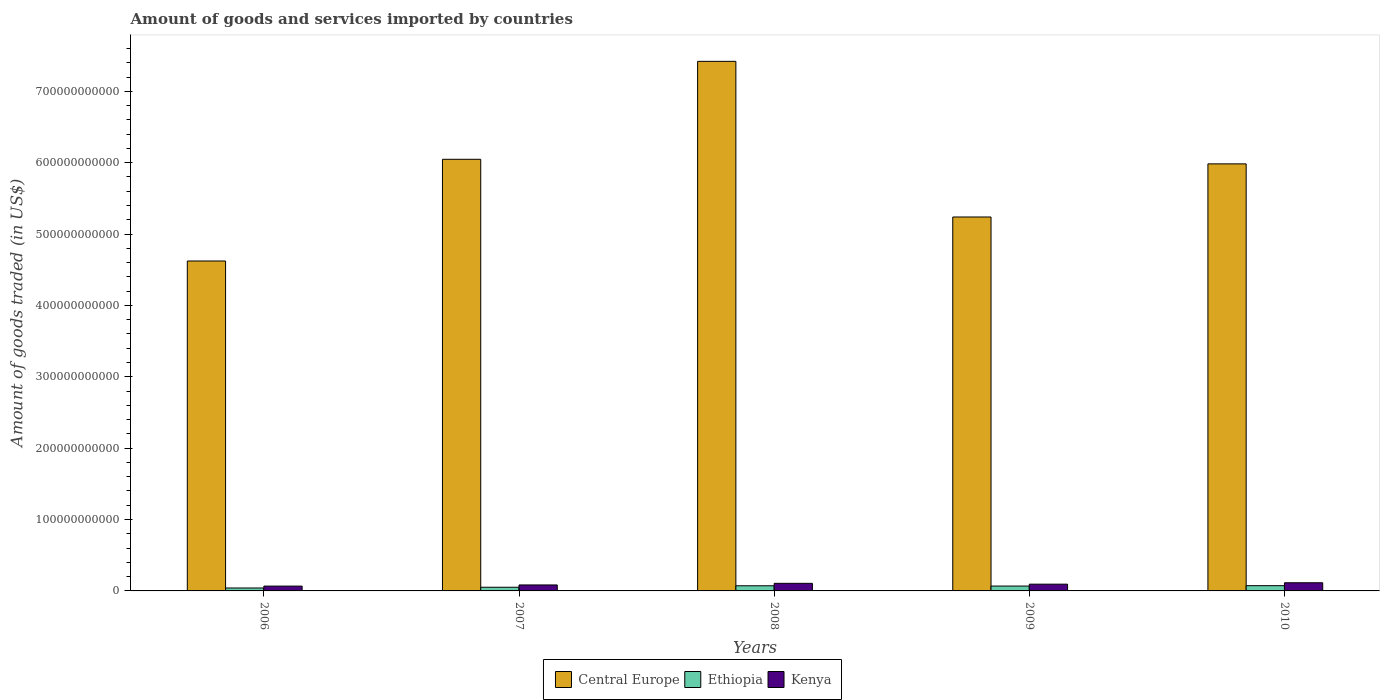How many different coloured bars are there?
Provide a succinct answer. 3. What is the label of the 4th group of bars from the left?
Your answer should be compact. 2009. In how many cases, is the number of bars for a given year not equal to the number of legend labels?
Your answer should be very brief. 0. What is the total amount of goods and services imported in Ethiopia in 2006?
Make the answer very short. 4.11e+09. Across all years, what is the maximum total amount of goods and services imported in Ethiopia?
Ensure brevity in your answer.  7.36e+09. Across all years, what is the minimum total amount of goods and services imported in Kenya?
Provide a succinct answer. 6.75e+09. In which year was the total amount of goods and services imported in Central Europe maximum?
Provide a short and direct response. 2008. In which year was the total amount of goods and services imported in Kenya minimum?
Keep it short and to the point. 2006. What is the total total amount of goods and services imported in Central Europe in the graph?
Offer a terse response. 2.93e+12. What is the difference between the total amount of goods and services imported in Ethiopia in 2009 and that in 2010?
Make the answer very short. -5.45e+08. What is the difference between the total amount of goods and services imported in Central Europe in 2008 and the total amount of goods and services imported in Ethiopia in 2010?
Your answer should be compact. 7.35e+11. What is the average total amount of goods and services imported in Kenya per year?
Your response must be concise. 9.33e+09. In the year 2010, what is the difference between the total amount of goods and services imported in Kenya and total amount of goods and services imported in Ethiopia?
Offer a very short reply. 4.08e+09. What is the ratio of the total amount of goods and services imported in Kenya in 2007 to that in 2008?
Keep it short and to the point. 0.79. Is the total amount of goods and services imported in Ethiopia in 2008 less than that in 2010?
Offer a terse response. Yes. Is the difference between the total amount of goods and services imported in Kenya in 2009 and 2010 greater than the difference between the total amount of goods and services imported in Ethiopia in 2009 and 2010?
Ensure brevity in your answer.  No. What is the difference between the highest and the second highest total amount of goods and services imported in Ethiopia?
Offer a terse response. 1.58e+08. What is the difference between the highest and the lowest total amount of goods and services imported in Kenya?
Ensure brevity in your answer.  4.69e+09. What does the 2nd bar from the left in 2007 represents?
Make the answer very short. Ethiopia. What does the 2nd bar from the right in 2009 represents?
Offer a terse response. Ethiopia. How many years are there in the graph?
Provide a short and direct response. 5. What is the difference between two consecutive major ticks on the Y-axis?
Make the answer very short. 1.00e+11. Are the values on the major ticks of Y-axis written in scientific E-notation?
Your response must be concise. No. Does the graph contain any zero values?
Make the answer very short. No. How many legend labels are there?
Make the answer very short. 3. How are the legend labels stacked?
Provide a short and direct response. Horizontal. What is the title of the graph?
Offer a very short reply. Amount of goods and services imported by countries. Does "Malta" appear as one of the legend labels in the graph?
Your response must be concise. No. What is the label or title of the X-axis?
Ensure brevity in your answer.  Years. What is the label or title of the Y-axis?
Offer a terse response. Amount of goods traded (in US$). What is the Amount of goods traded (in US$) of Central Europe in 2006?
Offer a very short reply. 4.62e+11. What is the Amount of goods traded (in US$) of Ethiopia in 2006?
Offer a terse response. 4.11e+09. What is the Amount of goods traded (in US$) of Kenya in 2006?
Offer a very short reply. 6.75e+09. What is the Amount of goods traded (in US$) of Central Europe in 2007?
Ensure brevity in your answer.  6.05e+11. What is the Amount of goods traded (in US$) in Ethiopia in 2007?
Your response must be concise. 5.16e+09. What is the Amount of goods traded (in US$) of Kenya in 2007?
Give a very brief answer. 8.37e+09. What is the Amount of goods traded (in US$) in Central Europe in 2008?
Offer a terse response. 7.42e+11. What is the Amount of goods traded (in US$) of Ethiopia in 2008?
Make the answer very short. 7.21e+09. What is the Amount of goods traded (in US$) in Kenya in 2008?
Your response must be concise. 1.06e+1. What is the Amount of goods traded (in US$) in Central Europe in 2009?
Make the answer very short. 5.24e+11. What is the Amount of goods traded (in US$) of Ethiopia in 2009?
Make the answer very short. 6.82e+09. What is the Amount of goods traded (in US$) in Kenya in 2009?
Give a very brief answer. 9.46e+09. What is the Amount of goods traded (in US$) of Central Europe in 2010?
Offer a very short reply. 5.98e+11. What is the Amount of goods traded (in US$) of Ethiopia in 2010?
Offer a terse response. 7.36e+09. What is the Amount of goods traded (in US$) in Kenya in 2010?
Provide a succinct answer. 1.14e+1. Across all years, what is the maximum Amount of goods traded (in US$) in Central Europe?
Your answer should be compact. 7.42e+11. Across all years, what is the maximum Amount of goods traded (in US$) in Ethiopia?
Provide a succinct answer. 7.36e+09. Across all years, what is the maximum Amount of goods traded (in US$) in Kenya?
Your response must be concise. 1.14e+1. Across all years, what is the minimum Amount of goods traded (in US$) of Central Europe?
Give a very brief answer. 4.62e+11. Across all years, what is the minimum Amount of goods traded (in US$) in Ethiopia?
Keep it short and to the point. 4.11e+09. Across all years, what is the minimum Amount of goods traded (in US$) of Kenya?
Offer a very short reply. 6.75e+09. What is the total Amount of goods traded (in US$) in Central Europe in the graph?
Provide a succinct answer. 2.93e+12. What is the total Amount of goods traded (in US$) of Ethiopia in the graph?
Keep it short and to the point. 3.07e+1. What is the total Amount of goods traded (in US$) of Kenya in the graph?
Offer a very short reply. 4.67e+1. What is the difference between the Amount of goods traded (in US$) in Central Europe in 2006 and that in 2007?
Provide a short and direct response. -1.42e+11. What is the difference between the Amount of goods traded (in US$) of Ethiopia in 2006 and that in 2007?
Provide a succinct answer. -1.05e+09. What is the difference between the Amount of goods traded (in US$) of Kenya in 2006 and that in 2007?
Ensure brevity in your answer.  -1.62e+09. What is the difference between the Amount of goods traded (in US$) of Central Europe in 2006 and that in 2008?
Provide a short and direct response. -2.80e+11. What is the difference between the Amount of goods traded (in US$) in Ethiopia in 2006 and that in 2008?
Make the answer very short. -3.10e+09. What is the difference between the Amount of goods traded (in US$) of Kenya in 2006 and that in 2008?
Ensure brevity in your answer.  -3.88e+09. What is the difference between the Amount of goods traded (in US$) of Central Europe in 2006 and that in 2009?
Offer a terse response. -6.17e+1. What is the difference between the Amount of goods traded (in US$) of Ethiopia in 2006 and that in 2009?
Your answer should be compact. -2.71e+09. What is the difference between the Amount of goods traded (in US$) in Kenya in 2006 and that in 2009?
Your response must be concise. -2.71e+09. What is the difference between the Amount of goods traded (in US$) of Central Europe in 2006 and that in 2010?
Give a very brief answer. -1.36e+11. What is the difference between the Amount of goods traded (in US$) in Ethiopia in 2006 and that in 2010?
Your answer should be compact. -3.26e+09. What is the difference between the Amount of goods traded (in US$) of Kenya in 2006 and that in 2010?
Make the answer very short. -4.69e+09. What is the difference between the Amount of goods traded (in US$) of Central Europe in 2007 and that in 2008?
Make the answer very short. -1.37e+11. What is the difference between the Amount of goods traded (in US$) of Ethiopia in 2007 and that in 2008?
Give a very brief answer. -2.05e+09. What is the difference between the Amount of goods traded (in US$) of Kenya in 2007 and that in 2008?
Make the answer very short. -2.27e+09. What is the difference between the Amount of goods traded (in US$) of Central Europe in 2007 and that in 2009?
Provide a short and direct response. 8.08e+1. What is the difference between the Amount of goods traded (in US$) in Ethiopia in 2007 and that in 2009?
Give a very brief answer. -1.66e+09. What is the difference between the Amount of goods traded (in US$) in Kenya in 2007 and that in 2009?
Your answer should be very brief. -1.09e+09. What is the difference between the Amount of goods traded (in US$) in Central Europe in 2007 and that in 2010?
Your answer should be compact. 6.40e+09. What is the difference between the Amount of goods traded (in US$) in Ethiopia in 2007 and that in 2010?
Ensure brevity in your answer.  -2.21e+09. What is the difference between the Amount of goods traded (in US$) in Kenya in 2007 and that in 2010?
Offer a terse response. -3.07e+09. What is the difference between the Amount of goods traded (in US$) of Central Europe in 2008 and that in 2009?
Offer a terse response. 2.18e+11. What is the difference between the Amount of goods traded (in US$) in Ethiopia in 2008 and that in 2009?
Provide a succinct answer. 3.87e+08. What is the difference between the Amount of goods traded (in US$) in Kenya in 2008 and that in 2009?
Your answer should be very brief. 1.17e+09. What is the difference between the Amount of goods traded (in US$) of Central Europe in 2008 and that in 2010?
Ensure brevity in your answer.  1.44e+11. What is the difference between the Amount of goods traded (in US$) of Ethiopia in 2008 and that in 2010?
Make the answer very short. -1.58e+08. What is the difference between the Amount of goods traded (in US$) in Kenya in 2008 and that in 2010?
Give a very brief answer. -8.07e+08. What is the difference between the Amount of goods traded (in US$) of Central Europe in 2009 and that in 2010?
Ensure brevity in your answer.  -7.44e+1. What is the difference between the Amount of goods traded (in US$) in Ethiopia in 2009 and that in 2010?
Ensure brevity in your answer.  -5.45e+08. What is the difference between the Amount of goods traded (in US$) in Kenya in 2009 and that in 2010?
Keep it short and to the point. -1.98e+09. What is the difference between the Amount of goods traded (in US$) in Central Europe in 2006 and the Amount of goods traded (in US$) in Ethiopia in 2007?
Keep it short and to the point. 4.57e+11. What is the difference between the Amount of goods traded (in US$) in Central Europe in 2006 and the Amount of goods traded (in US$) in Kenya in 2007?
Your answer should be compact. 4.54e+11. What is the difference between the Amount of goods traded (in US$) of Ethiopia in 2006 and the Amount of goods traded (in US$) of Kenya in 2007?
Your answer should be very brief. -4.26e+09. What is the difference between the Amount of goods traded (in US$) of Central Europe in 2006 and the Amount of goods traded (in US$) of Ethiopia in 2008?
Your answer should be compact. 4.55e+11. What is the difference between the Amount of goods traded (in US$) of Central Europe in 2006 and the Amount of goods traded (in US$) of Kenya in 2008?
Your answer should be compact. 4.52e+11. What is the difference between the Amount of goods traded (in US$) of Ethiopia in 2006 and the Amount of goods traded (in US$) of Kenya in 2008?
Offer a terse response. -6.53e+09. What is the difference between the Amount of goods traded (in US$) of Central Europe in 2006 and the Amount of goods traded (in US$) of Ethiopia in 2009?
Ensure brevity in your answer.  4.55e+11. What is the difference between the Amount of goods traded (in US$) in Central Europe in 2006 and the Amount of goods traded (in US$) in Kenya in 2009?
Make the answer very short. 4.53e+11. What is the difference between the Amount of goods traded (in US$) in Ethiopia in 2006 and the Amount of goods traded (in US$) in Kenya in 2009?
Your answer should be compact. -5.36e+09. What is the difference between the Amount of goods traded (in US$) in Central Europe in 2006 and the Amount of goods traded (in US$) in Ethiopia in 2010?
Your answer should be compact. 4.55e+11. What is the difference between the Amount of goods traded (in US$) of Central Europe in 2006 and the Amount of goods traded (in US$) of Kenya in 2010?
Ensure brevity in your answer.  4.51e+11. What is the difference between the Amount of goods traded (in US$) in Ethiopia in 2006 and the Amount of goods traded (in US$) in Kenya in 2010?
Offer a terse response. -7.34e+09. What is the difference between the Amount of goods traded (in US$) in Central Europe in 2007 and the Amount of goods traded (in US$) in Ethiopia in 2008?
Your answer should be very brief. 5.98e+11. What is the difference between the Amount of goods traded (in US$) of Central Europe in 2007 and the Amount of goods traded (in US$) of Kenya in 2008?
Your answer should be compact. 5.94e+11. What is the difference between the Amount of goods traded (in US$) in Ethiopia in 2007 and the Amount of goods traded (in US$) in Kenya in 2008?
Give a very brief answer. -5.48e+09. What is the difference between the Amount of goods traded (in US$) of Central Europe in 2007 and the Amount of goods traded (in US$) of Ethiopia in 2009?
Your answer should be compact. 5.98e+11. What is the difference between the Amount of goods traded (in US$) in Central Europe in 2007 and the Amount of goods traded (in US$) in Kenya in 2009?
Your answer should be very brief. 5.95e+11. What is the difference between the Amount of goods traded (in US$) in Ethiopia in 2007 and the Amount of goods traded (in US$) in Kenya in 2009?
Your answer should be very brief. -4.31e+09. What is the difference between the Amount of goods traded (in US$) of Central Europe in 2007 and the Amount of goods traded (in US$) of Ethiopia in 2010?
Provide a succinct answer. 5.97e+11. What is the difference between the Amount of goods traded (in US$) in Central Europe in 2007 and the Amount of goods traded (in US$) in Kenya in 2010?
Your answer should be very brief. 5.93e+11. What is the difference between the Amount of goods traded (in US$) in Ethiopia in 2007 and the Amount of goods traded (in US$) in Kenya in 2010?
Your response must be concise. -6.29e+09. What is the difference between the Amount of goods traded (in US$) in Central Europe in 2008 and the Amount of goods traded (in US$) in Ethiopia in 2009?
Give a very brief answer. 7.35e+11. What is the difference between the Amount of goods traded (in US$) in Central Europe in 2008 and the Amount of goods traded (in US$) in Kenya in 2009?
Your answer should be compact. 7.32e+11. What is the difference between the Amount of goods traded (in US$) of Ethiopia in 2008 and the Amount of goods traded (in US$) of Kenya in 2009?
Provide a short and direct response. -2.25e+09. What is the difference between the Amount of goods traded (in US$) of Central Europe in 2008 and the Amount of goods traded (in US$) of Ethiopia in 2010?
Provide a short and direct response. 7.35e+11. What is the difference between the Amount of goods traded (in US$) of Central Europe in 2008 and the Amount of goods traded (in US$) of Kenya in 2010?
Provide a short and direct response. 7.31e+11. What is the difference between the Amount of goods traded (in US$) in Ethiopia in 2008 and the Amount of goods traded (in US$) in Kenya in 2010?
Your response must be concise. -4.24e+09. What is the difference between the Amount of goods traded (in US$) of Central Europe in 2009 and the Amount of goods traded (in US$) of Ethiopia in 2010?
Give a very brief answer. 5.17e+11. What is the difference between the Amount of goods traded (in US$) of Central Europe in 2009 and the Amount of goods traded (in US$) of Kenya in 2010?
Keep it short and to the point. 5.12e+11. What is the difference between the Amount of goods traded (in US$) of Ethiopia in 2009 and the Amount of goods traded (in US$) of Kenya in 2010?
Ensure brevity in your answer.  -4.62e+09. What is the average Amount of goods traded (in US$) in Central Europe per year?
Your response must be concise. 5.86e+11. What is the average Amount of goods traded (in US$) in Ethiopia per year?
Provide a succinct answer. 6.13e+09. What is the average Amount of goods traded (in US$) of Kenya per year?
Keep it short and to the point. 9.33e+09. In the year 2006, what is the difference between the Amount of goods traded (in US$) in Central Europe and Amount of goods traded (in US$) in Ethiopia?
Ensure brevity in your answer.  4.58e+11. In the year 2006, what is the difference between the Amount of goods traded (in US$) in Central Europe and Amount of goods traded (in US$) in Kenya?
Provide a short and direct response. 4.55e+11. In the year 2006, what is the difference between the Amount of goods traded (in US$) in Ethiopia and Amount of goods traded (in US$) in Kenya?
Give a very brief answer. -2.65e+09. In the year 2007, what is the difference between the Amount of goods traded (in US$) in Central Europe and Amount of goods traded (in US$) in Ethiopia?
Provide a short and direct response. 6.00e+11. In the year 2007, what is the difference between the Amount of goods traded (in US$) of Central Europe and Amount of goods traded (in US$) of Kenya?
Ensure brevity in your answer.  5.96e+11. In the year 2007, what is the difference between the Amount of goods traded (in US$) in Ethiopia and Amount of goods traded (in US$) in Kenya?
Give a very brief answer. -3.21e+09. In the year 2008, what is the difference between the Amount of goods traded (in US$) of Central Europe and Amount of goods traded (in US$) of Ethiopia?
Your answer should be compact. 7.35e+11. In the year 2008, what is the difference between the Amount of goods traded (in US$) of Central Europe and Amount of goods traded (in US$) of Kenya?
Give a very brief answer. 7.31e+11. In the year 2008, what is the difference between the Amount of goods traded (in US$) of Ethiopia and Amount of goods traded (in US$) of Kenya?
Make the answer very short. -3.43e+09. In the year 2009, what is the difference between the Amount of goods traded (in US$) in Central Europe and Amount of goods traded (in US$) in Ethiopia?
Offer a very short reply. 5.17e+11. In the year 2009, what is the difference between the Amount of goods traded (in US$) in Central Europe and Amount of goods traded (in US$) in Kenya?
Your response must be concise. 5.14e+11. In the year 2009, what is the difference between the Amount of goods traded (in US$) of Ethiopia and Amount of goods traded (in US$) of Kenya?
Provide a short and direct response. -2.64e+09. In the year 2010, what is the difference between the Amount of goods traded (in US$) in Central Europe and Amount of goods traded (in US$) in Ethiopia?
Offer a very short reply. 5.91e+11. In the year 2010, what is the difference between the Amount of goods traded (in US$) in Central Europe and Amount of goods traded (in US$) in Kenya?
Your answer should be very brief. 5.87e+11. In the year 2010, what is the difference between the Amount of goods traded (in US$) in Ethiopia and Amount of goods traded (in US$) in Kenya?
Ensure brevity in your answer.  -4.08e+09. What is the ratio of the Amount of goods traded (in US$) of Central Europe in 2006 to that in 2007?
Ensure brevity in your answer.  0.76. What is the ratio of the Amount of goods traded (in US$) in Ethiopia in 2006 to that in 2007?
Ensure brevity in your answer.  0.8. What is the ratio of the Amount of goods traded (in US$) of Kenya in 2006 to that in 2007?
Provide a short and direct response. 0.81. What is the ratio of the Amount of goods traded (in US$) of Central Europe in 2006 to that in 2008?
Offer a terse response. 0.62. What is the ratio of the Amount of goods traded (in US$) of Ethiopia in 2006 to that in 2008?
Your answer should be compact. 0.57. What is the ratio of the Amount of goods traded (in US$) of Kenya in 2006 to that in 2008?
Ensure brevity in your answer.  0.63. What is the ratio of the Amount of goods traded (in US$) of Central Europe in 2006 to that in 2009?
Keep it short and to the point. 0.88. What is the ratio of the Amount of goods traded (in US$) of Ethiopia in 2006 to that in 2009?
Provide a succinct answer. 0.6. What is the ratio of the Amount of goods traded (in US$) of Kenya in 2006 to that in 2009?
Give a very brief answer. 0.71. What is the ratio of the Amount of goods traded (in US$) in Central Europe in 2006 to that in 2010?
Keep it short and to the point. 0.77. What is the ratio of the Amount of goods traded (in US$) in Ethiopia in 2006 to that in 2010?
Make the answer very short. 0.56. What is the ratio of the Amount of goods traded (in US$) in Kenya in 2006 to that in 2010?
Keep it short and to the point. 0.59. What is the ratio of the Amount of goods traded (in US$) of Central Europe in 2007 to that in 2008?
Ensure brevity in your answer.  0.82. What is the ratio of the Amount of goods traded (in US$) of Ethiopia in 2007 to that in 2008?
Your response must be concise. 0.72. What is the ratio of the Amount of goods traded (in US$) of Kenya in 2007 to that in 2008?
Provide a short and direct response. 0.79. What is the ratio of the Amount of goods traded (in US$) of Central Europe in 2007 to that in 2009?
Give a very brief answer. 1.15. What is the ratio of the Amount of goods traded (in US$) of Ethiopia in 2007 to that in 2009?
Provide a succinct answer. 0.76. What is the ratio of the Amount of goods traded (in US$) in Kenya in 2007 to that in 2009?
Your answer should be very brief. 0.88. What is the ratio of the Amount of goods traded (in US$) in Central Europe in 2007 to that in 2010?
Offer a very short reply. 1.01. What is the ratio of the Amount of goods traded (in US$) in Ethiopia in 2007 to that in 2010?
Make the answer very short. 0.7. What is the ratio of the Amount of goods traded (in US$) of Kenya in 2007 to that in 2010?
Offer a very short reply. 0.73. What is the ratio of the Amount of goods traded (in US$) in Central Europe in 2008 to that in 2009?
Your response must be concise. 1.42. What is the ratio of the Amount of goods traded (in US$) of Ethiopia in 2008 to that in 2009?
Provide a short and direct response. 1.06. What is the ratio of the Amount of goods traded (in US$) of Kenya in 2008 to that in 2009?
Ensure brevity in your answer.  1.12. What is the ratio of the Amount of goods traded (in US$) in Central Europe in 2008 to that in 2010?
Keep it short and to the point. 1.24. What is the ratio of the Amount of goods traded (in US$) in Ethiopia in 2008 to that in 2010?
Ensure brevity in your answer.  0.98. What is the ratio of the Amount of goods traded (in US$) of Kenya in 2008 to that in 2010?
Ensure brevity in your answer.  0.93. What is the ratio of the Amount of goods traded (in US$) in Central Europe in 2009 to that in 2010?
Give a very brief answer. 0.88. What is the ratio of the Amount of goods traded (in US$) of Ethiopia in 2009 to that in 2010?
Keep it short and to the point. 0.93. What is the ratio of the Amount of goods traded (in US$) in Kenya in 2009 to that in 2010?
Keep it short and to the point. 0.83. What is the difference between the highest and the second highest Amount of goods traded (in US$) of Central Europe?
Provide a short and direct response. 1.37e+11. What is the difference between the highest and the second highest Amount of goods traded (in US$) in Ethiopia?
Provide a succinct answer. 1.58e+08. What is the difference between the highest and the second highest Amount of goods traded (in US$) of Kenya?
Provide a short and direct response. 8.07e+08. What is the difference between the highest and the lowest Amount of goods traded (in US$) in Central Europe?
Your response must be concise. 2.80e+11. What is the difference between the highest and the lowest Amount of goods traded (in US$) of Ethiopia?
Your answer should be compact. 3.26e+09. What is the difference between the highest and the lowest Amount of goods traded (in US$) of Kenya?
Offer a very short reply. 4.69e+09. 